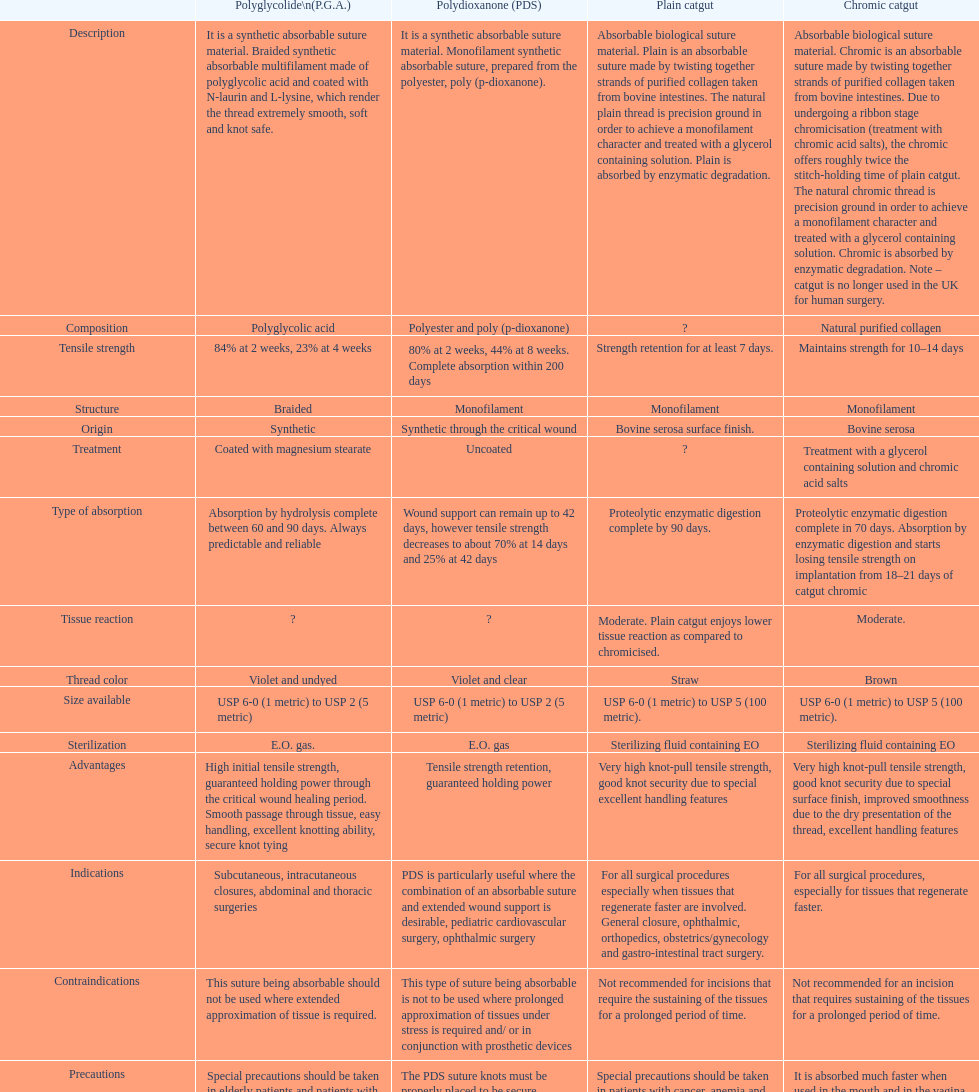Which suture can remain to at most 42 days Polydioxanone (PDS). 